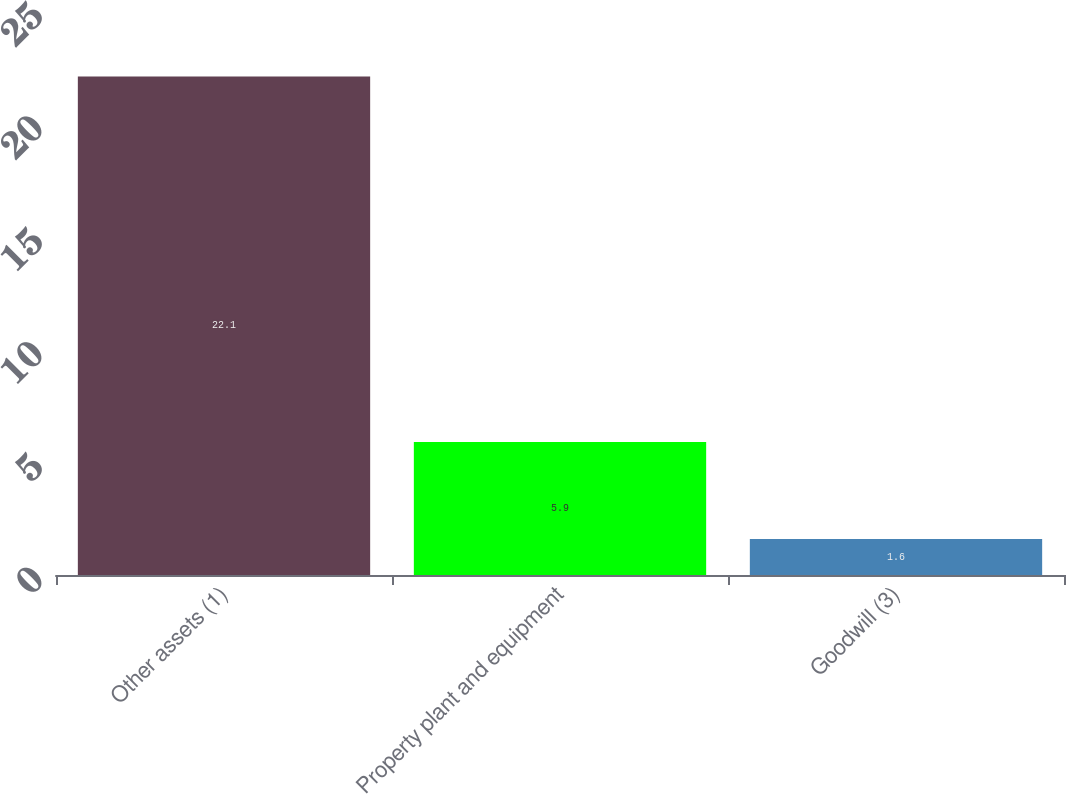Convert chart to OTSL. <chart><loc_0><loc_0><loc_500><loc_500><bar_chart><fcel>Other assets (1)<fcel>Property plant and equipment<fcel>Goodwill (3)<nl><fcel>22.1<fcel>5.9<fcel>1.6<nl></chart> 